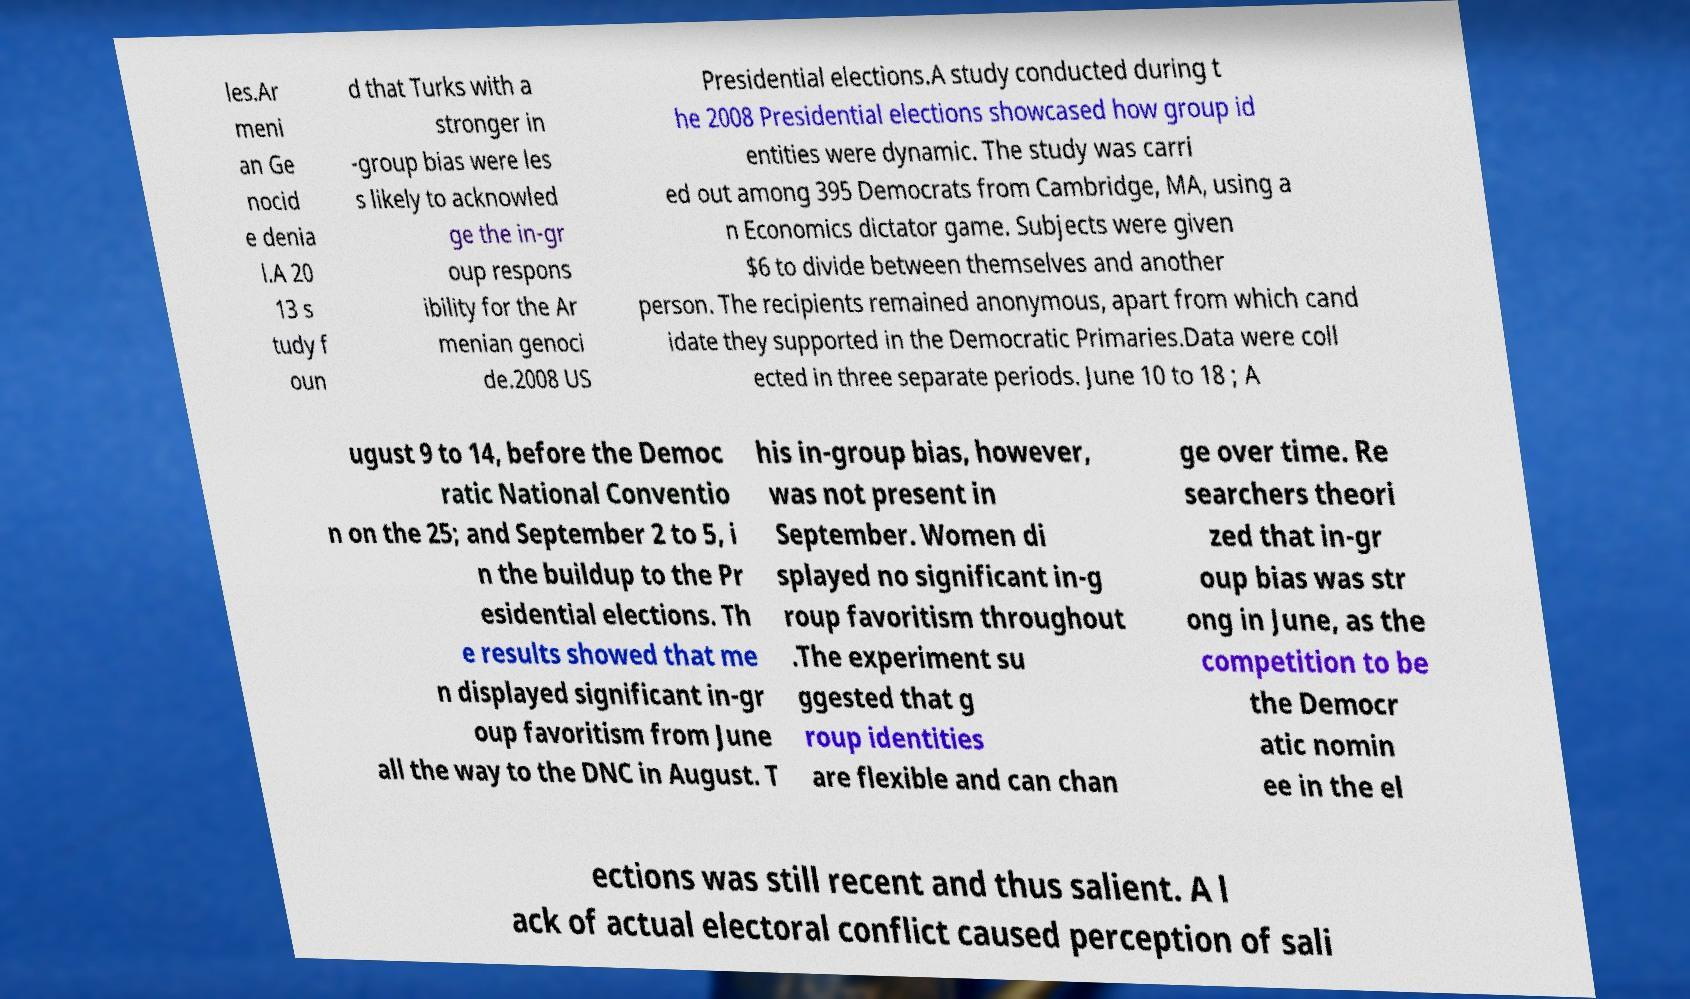Please identify and transcribe the text found in this image. les.Ar meni an Ge nocid e denia l.A 20 13 s tudy f oun d that Turks with a stronger in -group bias were les s likely to acknowled ge the in-gr oup respons ibility for the Ar menian genoci de.2008 US Presidential elections.A study conducted during t he 2008 Presidential elections showcased how group id entities were dynamic. The study was carri ed out among 395 Democrats from Cambridge, MA, using a n Economics dictator game. Subjects were given $6 to divide between themselves and another person. The recipients remained anonymous, apart from which cand idate they supported in the Democratic Primaries.Data were coll ected in three separate periods. June 10 to 18 ; A ugust 9 to 14, before the Democ ratic National Conventio n on the 25; and September 2 to 5, i n the buildup to the Pr esidential elections. Th e results showed that me n displayed significant in-gr oup favoritism from June all the way to the DNC in August. T his in-group bias, however, was not present in September. Women di splayed no significant in-g roup favoritism throughout .The experiment su ggested that g roup identities are flexible and can chan ge over time. Re searchers theori zed that in-gr oup bias was str ong in June, as the competition to be the Democr atic nomin ee in the el ections was still recent and thus salient. A l ack of actual electoral conflict caused perception of sali 